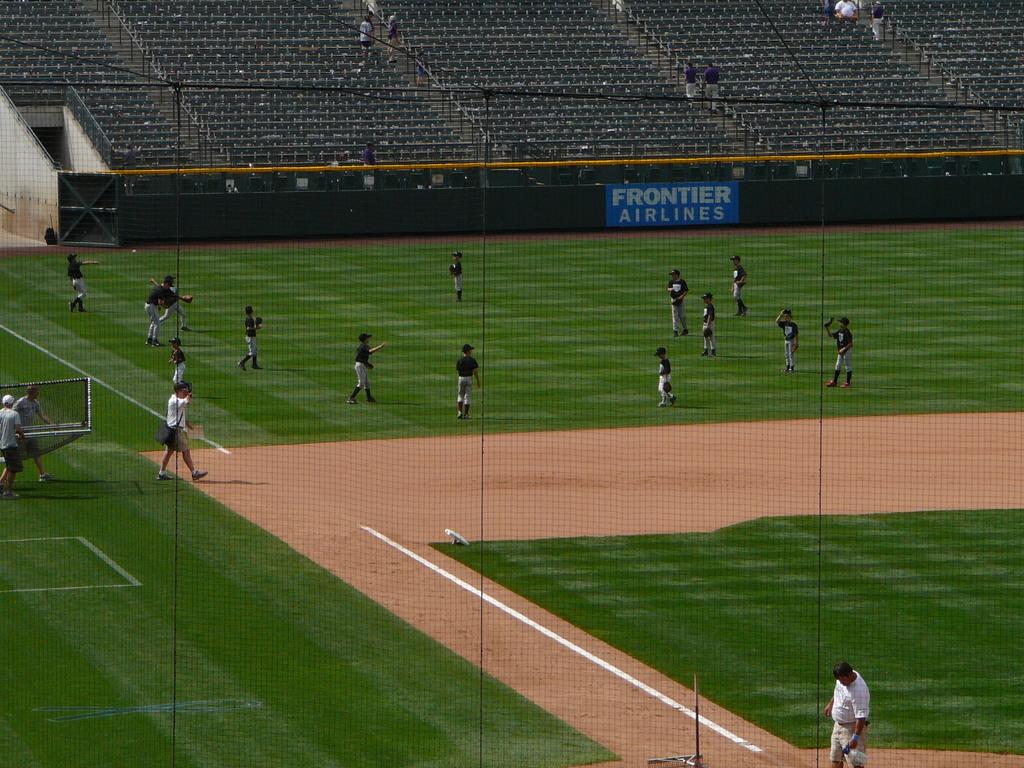What airlines is advertising?
Provide a succinct answer. Frontier. 